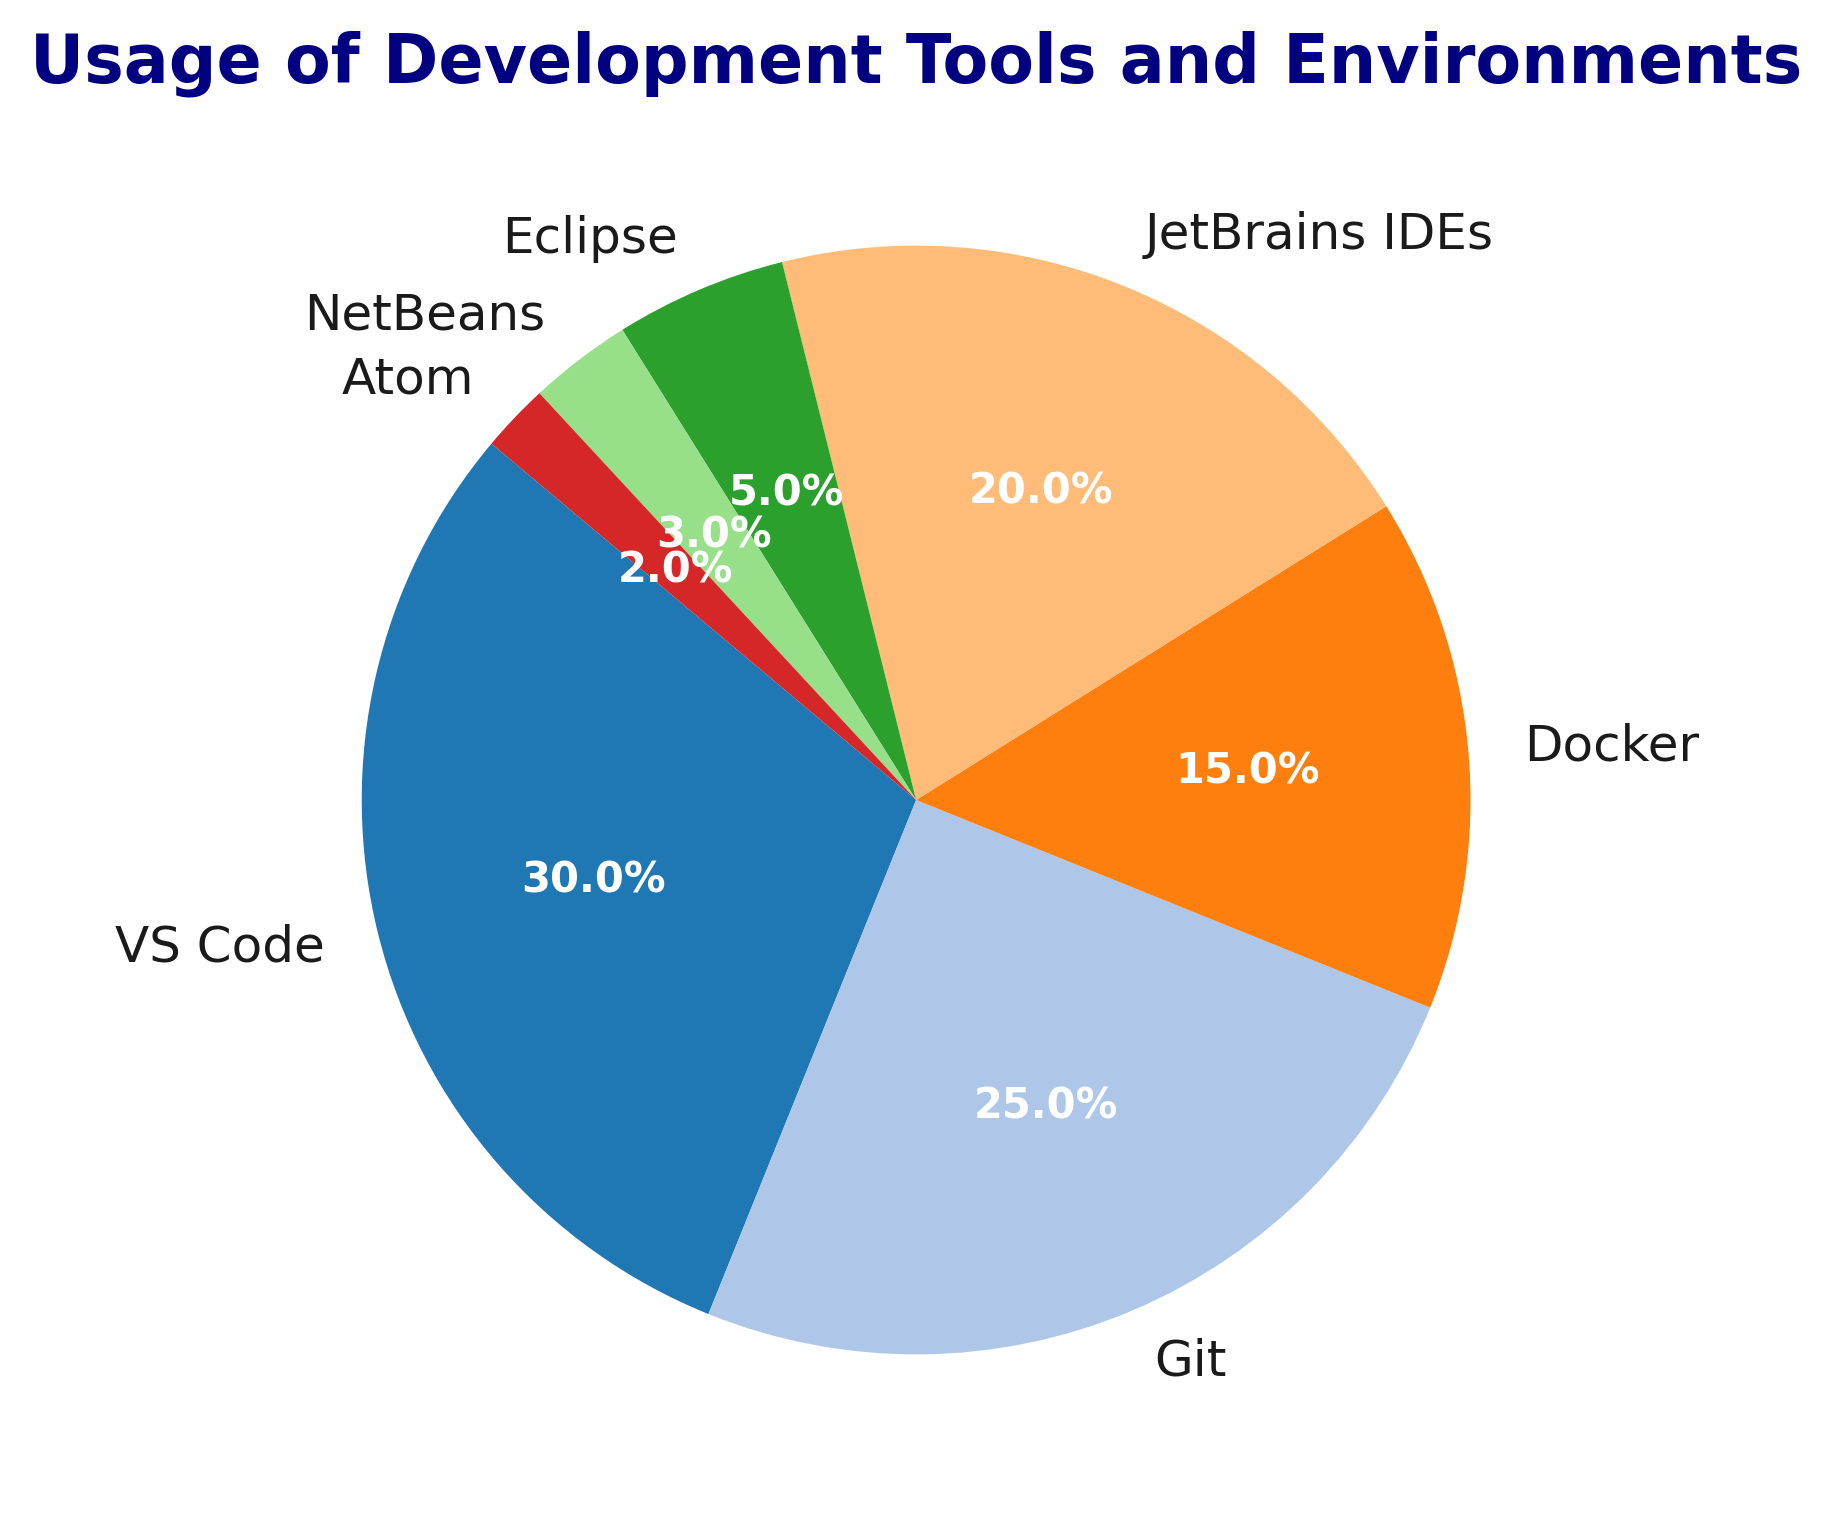Which tool has the highest usage percentage? The pie chart indicates the usage percentage of various development tools. By looking at the chart, identify which segment is the largest.
Answer: VS Code What's the combined usage percentage of JetBrains IDEs and VS Code? Add the usage percentages of both JetBrains IDEs (20%) and VS Code (30%) to get the total.
Answer: 50% Is the usage percentage of Git higher or lower than that of Docker? Compare the segments representing Git (25%) and Docker (15%). Note that Git's segment is larger.
Answer: Higher How many tools have usage percentages lower than 5%? Count the number of segments in the pie chart that represent usage percentages of less than 5% (Eclipse 5%, NetBeans 3%, Atom 2%).
Answer: 2 Which tool is represented by the darkest color in the chart? Look for the segment with the darkest shade. Depending on the 'tab20' colormap used, you might visually recognize Git in a darker shade.
Answer: Git What is the difference in the usage percentage between the top tool and the least used tool? Subtract the usage percentage of the least used tool Atom (2%) from the top tool VS Code (30%).
Answer: 28% Is the usage of NetBeans closer to the usage of Atom or Eclipse? Compare the differences: NetBeans (3%) to Atom (2%) for a difference of 1%, and NetBeans (3%) to Eclipse (5%) for a difference of 2%.
Answer: Atom What can be inferred about the total percentage usage of non-VS Code tools? Subtract VS Code's percentage (30%) from the total 100% to find the combined usage of the other tools.
Answer: 70% How does the usage percentage of JetBrains IDEs compare to Git? Analyze the segments and compare JetBrains IDEs (20%) to Git (25%). Note that JetBrains IDEs has a smaller percentage.
Answer: Lower What is the sum of the usage percentages for Git, Docker, and NetBeans? Add the percentages for Git (25%), Docker (15%), and NetBeans (3%) to get the total.
Answer: 43% 